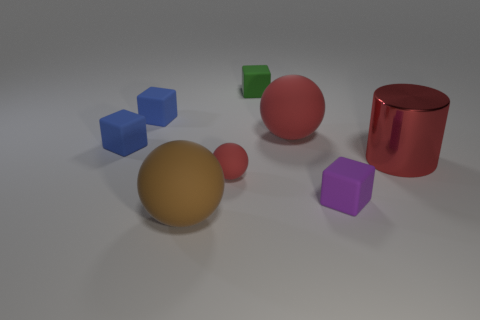The green matte object to the right of the matte thing in front of the purple cube is what shape?
Your answer should be very brief. Cube. Are there any cyan matte things that have the same shape as the brown thing?
Your answer should be compact. No. What is the shape of the purple thing that is the same size as the green block?
Offer a terse response. Cube. There is a tiny blue matte cube in front of the large rubber ball that is behind the cylinder; is there a blue cube to the right of it?
Make the answer very short. Yes. Are there any brown things of the same size as the brown rubber ball?
Make the answer very short. No. What size is the matte ball behind the red cylinder?
Provide a succinct answer. Large. There is a large ball that is left of the red rubber object that is to the left of the big rubber sphere that is right of the brown rubber sphere; what is its color?
Your response must be concise. Brown. What is the color of the rubber ball right of the red object that is in front of the red shiny thing?
Provide a short and direct response. Red. Is the number of tiny red things that are on the right side of the small purple rubber block greater than the number of cylinders to the right of the red cylinder?
Offer a very short reply. No. Do the red cylinder right of the brown object and the sphere in front of the tiny matte sphere have the same material?
Give a very brief answer. No. 